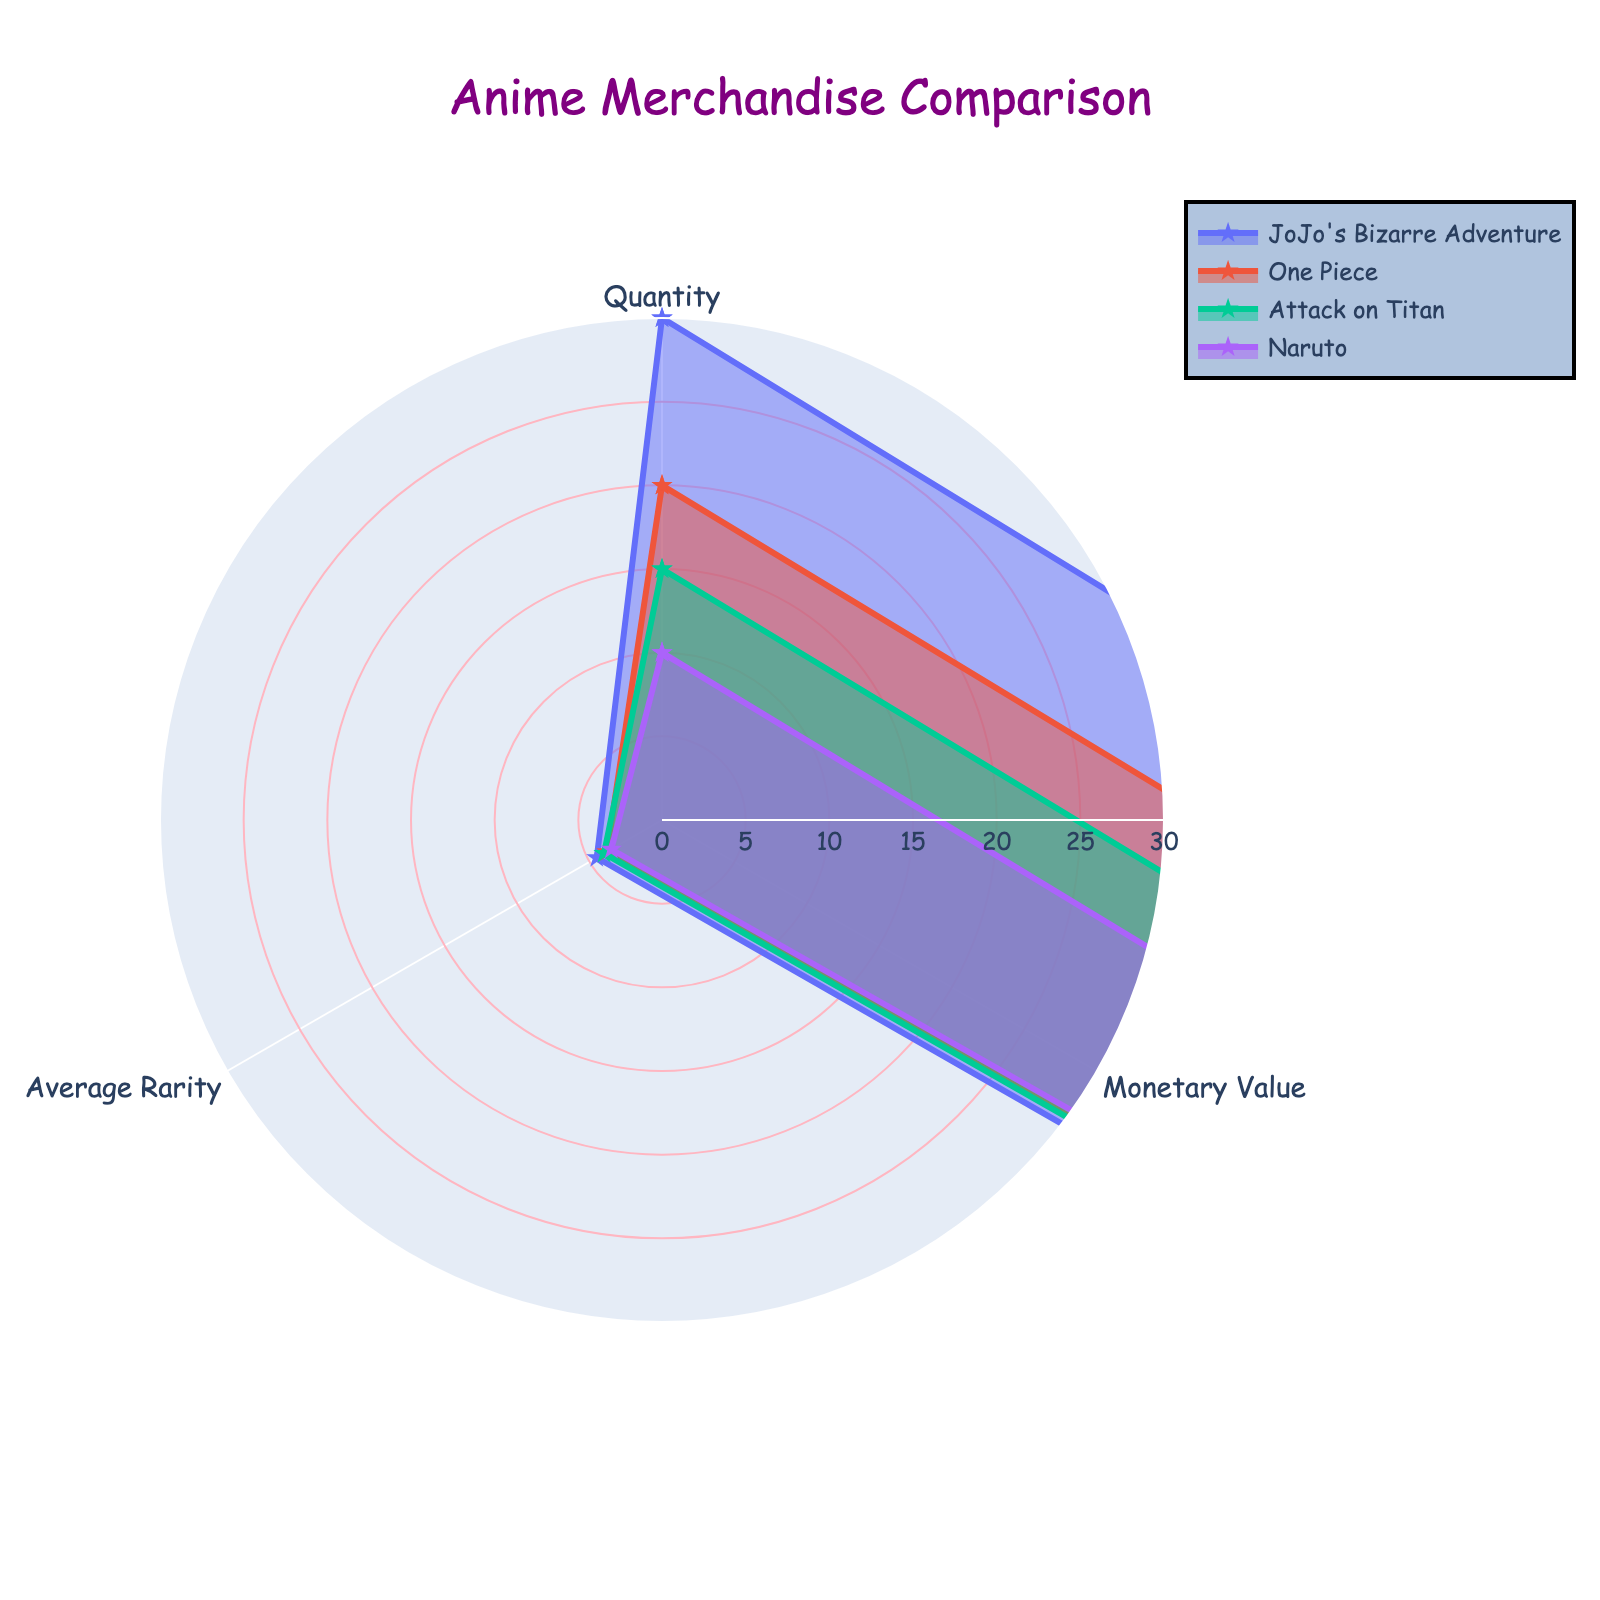what is the title of the fig? The title is usually displayed at the top of the figure and is central to understanding the overall theme of the plot. The title in this radar chart visibly mentions something related to "Anime Merchandise Comparison".
Answer: Anime Merchandise Comparison which category has the highest quantity? By comparing the "Quantity" values among different groups (JoJo's Bizarre Adventure, One Piece, Attack on Titan, Naruto), it is evident that the longest arm for the "Quantity" axis belongs to JoJo's Bizarre Adventure, indicating that it has the highest quantity.
Answer: JoJo's Bizarre Adventure What category represents the most Collectibles in terms of monetary value? To determine which category represents the highest monetary value, check the segment along the "Monetary Value" axis and identify the arm that extends furthest. This belongs to JoJo's Bizarre Adventure, indicating that it has the highest monetary value.
Answer: JoJo's Bizarre Adventure Between One Piece and Attack on Titan, which category is rarer on average? Rarity is compared on the "Average Rarity" axis. By visually comparing the values, you’ll observe that the arm for "Average Rarity" is longer for Attack on Titan than for One Piece. Thus, Attack on Titan is rarer on average.
Answer: Attack on Titan What are the respective maximum values on the radar chart? The maximum values for each axis can be found by checking the outer edge of the radar chart. For "Quantity," it is 30; for "Monetary Value," it is 1000; and for "Average Rarity," it is 4.5.
Answer: 30, 1000, 4.5 What is the total quantity of collectibles from all categories? Add the quantities for each category: 30 (JoJo's Bizarre Adventure) + 20 (One Piece) + 15 (Attack on Titan) + 10 (Naruto). The total is 75.
Answer: 75 Which category has the lowest values across all metrics? By comparing the segments for all three axes (Quantity, Monetary Value, Average Rarity) for each category, Naruto consistently shows the shortest arms, indicating it has the lowest values across all metrics.
Answer: Naruto What is the average monetary value of all categories combined? To find the average, sum up the monetary values of all categories and divide by the number of categories: (1000 (JoJo) + 800 (One Piece) + 600 (Attack on Titan) + 400 (Naruto)) / 4. The total value is 2800 / 4 = 700.
Answer: 700 Which category shows an inverse relationship between quantity and rarity? By examining the "Quantity" and "Average Rarity" axes for each category: One Piece has lower quantity values and also lower rarity values, indicating an inverse relation where more rare items do not correspond to a higher quantity.
Answer: One Piece 